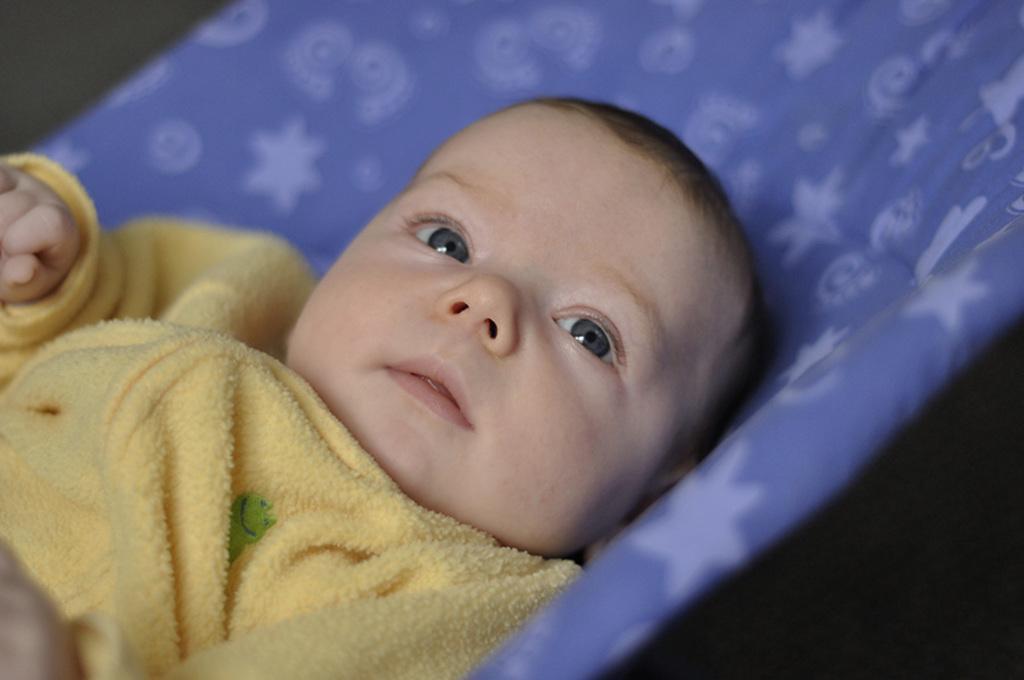Could you give a brief overview of what you see in this image? In this picture I can see there is a infant lying on a blue blanket and looking at right side. The backdrop is blurred. 